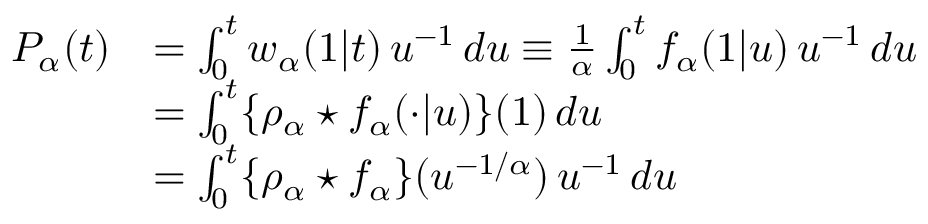<formula> <loc_0><loc_0><loc_500><loc_500>\begin{array} { r l } { P _ { \alpha } ( t ) } & { = \int _ { 0 } ^ { t } w _ { \alpha } ( 1 | t ) \, u ^ { - 1 } \, d u \equiv \frac { 1 } { \alpha } \int _ { 0 } ^ { t } f _ { \alpha } ( 1 | u ) \, u ^ { - 1 } \, d u } \\ & { = \int _ { 0 } ^ { t } \{ \rho _ { \alpha } ^ { * } f _ { \alpha } ( \cdot | u ) \} ( 1 ) \, d u } \\ & { = \int _ { 0 } ^ { t } \{ \rho _ { \alpha } ^ { * } f _ { \alpha } \} ( u ^ { - 1 / \alpha } ) \, u ^ { - 1 } \, d u } \end{array}</formula> 